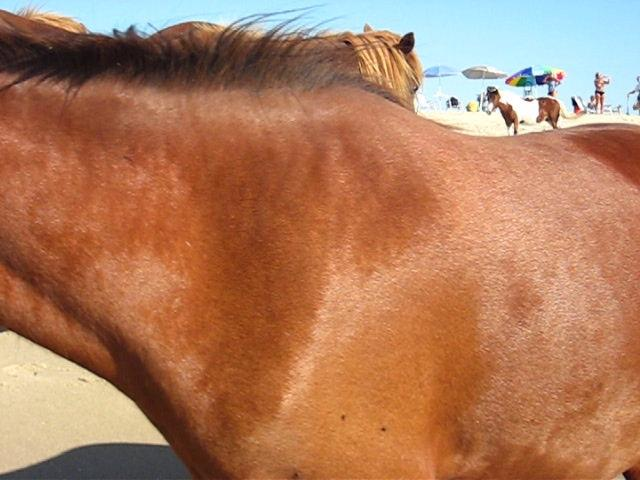What type flag elements appear in a pictured umbrella? rainbow 